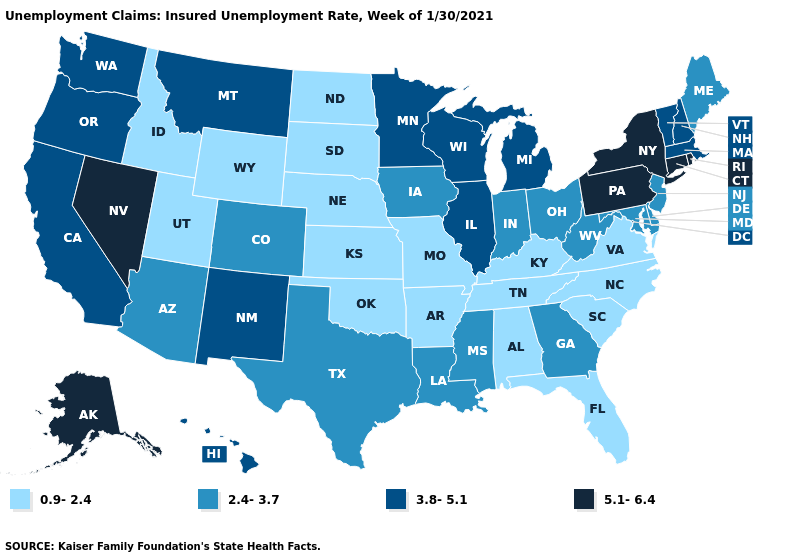What is the value of Tennessee?
Write a very short answer. 0.9-2.4. Name the states that have a value in the range 5.1-6.4?
Concise answer only. Alaska, Connecticut, Nevada, New York, Pennsylvania, Rhode Island. What is the value of Connecticut?
Quick response, please. 5.1-6.4. What is the lowest value in states that border Arizona?
Quick response, please. 0.9-2.4. Name the states that have a value in the range 2.4-3.7?
Write a very short answer. Arizona, Colorado, Delaware, Georgia, Indiana, Iowa, Louisiana, Maine, Maryland, Mississippi, New Jersey, Ohio, Texas, West Virginia. Among the states that border Georgia , which have the highest value?
Be succinct. Alabama, Florida, North Carolina, South Carolina, Tennessee. Does the first symbol in the legend represent the smallest category?
Concise answer only. Yes. What is the highest value in the South ?
Quick response, please. 2.4-3.7. What is the value of Delaware?
Short answer required. 2.4-3.7. Does Tennessee have a higher value than Nevada?
Give a very brief answer. No. Name the states that have a value in the range 2.4-3.7?
Short answer required. Arizona, Colorado, Delaware, Georgia, Indiana, Iowa, Louisiana, Maine, Maryland, Mississippi, New Jersey, Ohio, Texas, West Virginia. Does the map have missing data?
Be succinct. No. What is the value of Delaware?
Give a very brief answer. 2.4-3.7. What is the highest value in the USA?
Short answer required. 5.1-6.4. Which states have the highest value in the USA?
Give a very brief answer. Alaska, Connecticut, Nevada, New York, Pennsylvania, Rhode Island. 